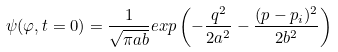<formula> <loc_0><loc_0><loc_500><loc_500>\psi ( \varphi , t = 0 ) = \frac { 1 } { \sqrt { \pi a b } } e x p \left ( - \frac { q ^ { 2 } } { 2 a ^ { 2 } } - \frac { ( p - p _ { i } ) ^ { 2 } } { 2 b ^ { 2 } } \right )</formula> 